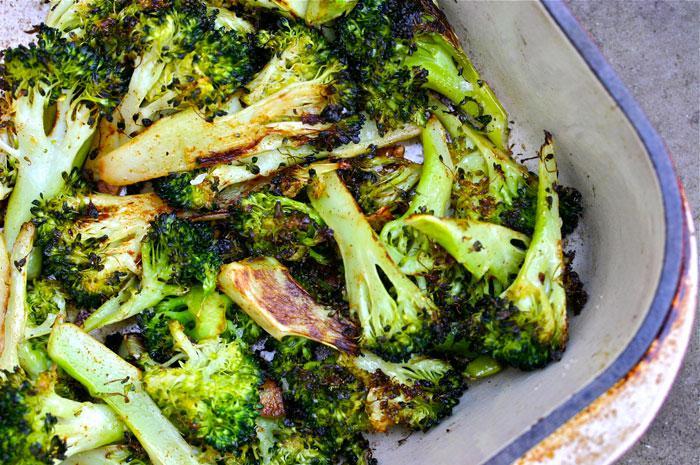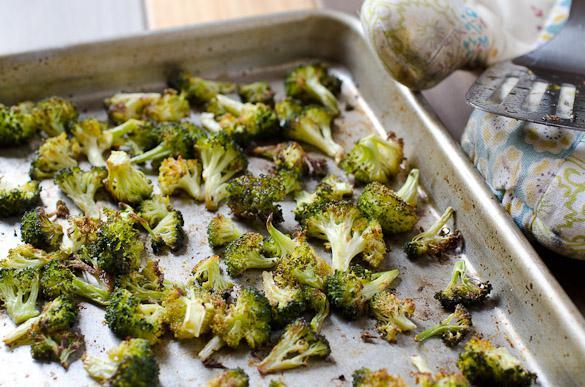The first image is the image on the left, the second image is the image on the right. Examine the images to the left and right. Is the description "The food in the right image is in a solid white bowl." accurate? Answer yes or no. No. The first image is the image on the left, the second image is the image on the right. Examine the images to the left and right. Is the description "There are two bowls of broccoli." accurate? Answer yes or no. No. 